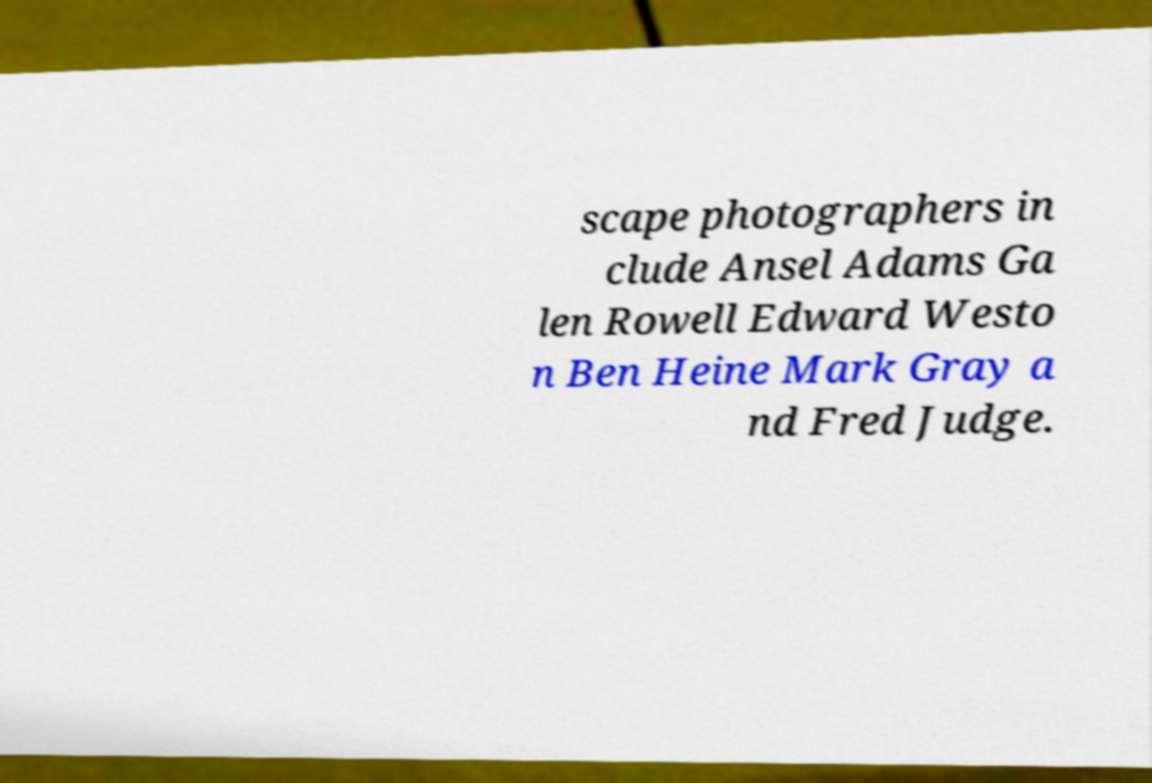For documentation purposes, I need the text within this image transcribed. Could you provide that? scape photographers in clude Ansel Adams Ga len Rowell Edward Westo n Ben Heine Mark Gray a nd Fred Judge. 